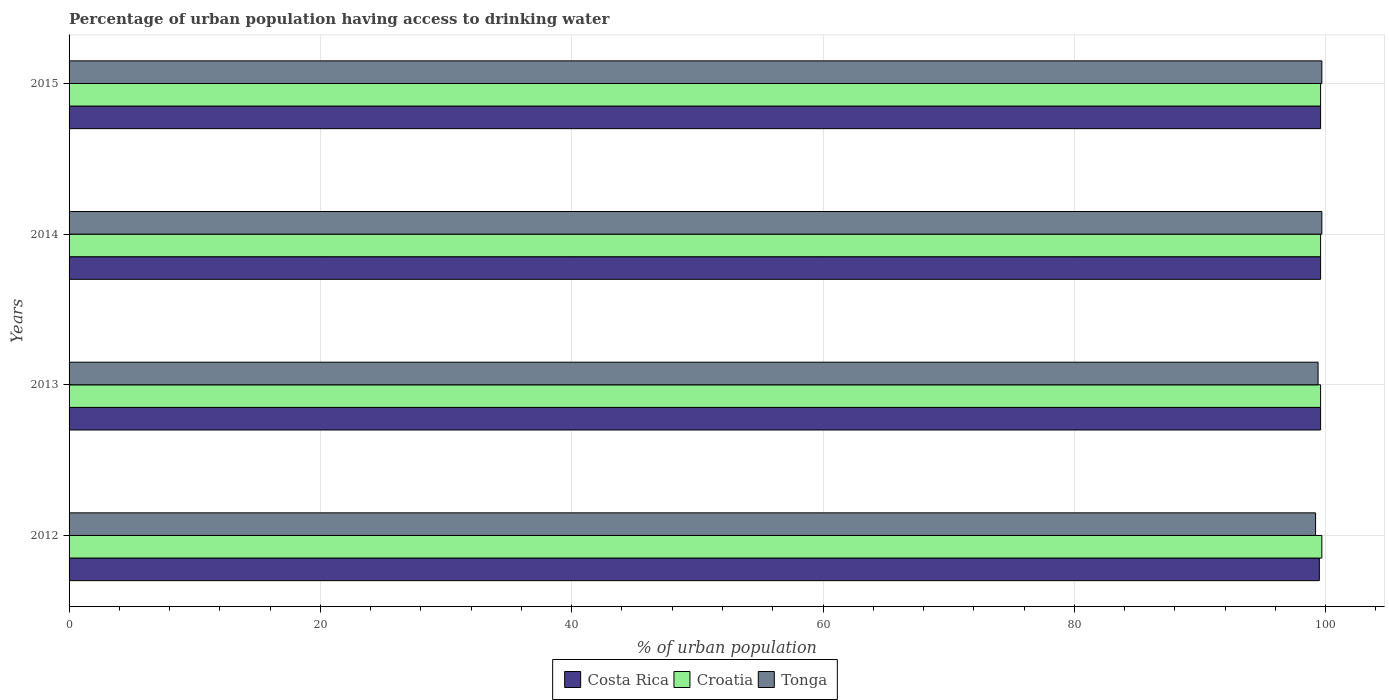How many different coloured bars are there?
Give a very brief answer. 3. Are the number of bars per tick equal to the number of legend labels?
Offer a terse response. Yes. Are the number of bars on each tick of the Y-axis equal?
Offer a very short reply. Yes. How many bars are there on the 2nd tick from the top?
Offer a very short reply. 3. How many bars are there on the 2nd tick from the bottom?
Ensure brevity in your answer.  3. What is the percentage of urban population having access to drinking water in Costa Rica in 2014?
Your answer should be compact. 99.6. Across all years, what is the maximum percentage of urban population having access to drinking water in Tonga?
Make the answer very short. 99.7. Across all years, what is the minimum percentage of urban population having access to drinking water in Costa Rica?
Give a very brief answer. 99.5. What is the total percentage of urban population having access to drinking water in Costa Rica in the graph?
Keep it short and to the point. 398.3. What is the difference between the percentage of urban population having access to drinking water in Tonga in 2012 and that in 2013?
Offer a very short reply. -0.2. What is the difference between the percentage of urban population having access to drinking water in Costa Rica in 2014 and the percentage of urban population having access to drinking water in Croatia in 2012?
Make the answer very short. -0.1. What is the average percentage of urban population having access to drinking water in Croatia per year?
Your response must be concise. 99.62. In the year 2015, what is the difference between the percentage of urban population having access to drinking water in Tonga and percentage of urban population having access to drinking water in Costa Rica?
Your answer should be very brief. 0.1. Is the percentage of urban population having access to drinking water in Costa Rica in 2012 less than that in 2014?
Ensure brevity in your answer.  Yes. What is the difference between the highest and the second highest percentage of urban population having access to drinking water in Costa Rica?
Provide a short and direct response. 0. What is the difference between the highest and the lowest percentage of urban population having access to drinking water in Costa Rica?
Offer a terse response. 0.1. What does the 3rd bar from the top in 2013 represents?
Keep it short and to the point. Costa Rica. What does the 3rd bar from the bottom in 2014 represents?
Your response must be concise. Tonga. Is it the case that in every year, the sum of the percentage of urban population having access to drinking water in Costa Rica and percentage of urban population having access to drinking water in Tonga is greater than the percentage of urban population having access to drinking water in Croatia?
Keep it short and to the point. Yes. How many bars are there?
Your answer should be compact. 12. Are the values on the major ticks of X-axis written in scientific E-notation?
Provide a succinct answer. No. Where does the legend appear in the graph?
Make the answer very short. Bottom center. What is the title of the graph?
Ensure brevity in your answer.  Percentage of urban population having access to drinking water. What is the label or title of the X-axis?
Offer a terse response. % of urban population. What is the % of urban population of Costa Rica in 2012?
Provide a succinct answer. 99.5. What is the % of urban population in Croatia in 2012?
Your answer should be very brief. 99.7. What is the % of urban population of Tonga in 2012?
Your answer should be compact. 99.2. What is the % of urban population of Costa Rica in 2013?
Ensure brevity in your answer.  99.6. What is the % of urban population of Croatia in 2013?
Your response must be concise. 99.6. What is the % of urban population of Tonga in 2013?
Keep it short and to the point. 99.4. What is the % of urban population in Costa Rica in 2014?
Offer a terse response. 99.6. What is the % of urban population in Croatia in 2014?
Make the answer very short. 99.6. What is the % of urban population in Tonga in 2014?
Provide a succinct answer. 99.7. What is the % of urban population of Costa Rica in 2015?
Ensure brevity in your answer.  99.6. What is the % of urban population in Croatia in 2015?
Provide a short and direct response. 99.6. What is the % of urban population of Tonga in 2015?
Ensure brevity in your answer.  99.7. Across all years, what is the maximum % of urban population of Costa Rica?
Provide a short and direct response. 99.6. Across all years, what is the maximum % of urban population of Croatia?
Ensure brevity in your answer.  99.7. Across all years, what is the maximum % of urban population in Tonga?
Make the answer very short. 99.7. Across all years, what is the minimum % of urban population of Costa Rica?
Your answer should be very brief. 99.5. Across all years, what is the minimum % of urban population of Croatia?
Make the answer very short. 99.6. Across all years, what is the minimum % of urban population in Tonga?
Offer a very short reply. 99.2. What is the total % of urban population of Costa Rica in the graph?
Your response must be concise. 398.3. What is the total % of urban population in Croatia in the graph?
Provide a short and direct response. 398.5. What is the total % of urban population in Tonga in the graph?
Provide a succinct answer. 398. What is the difference between the % of urban population in Costa Rica in 2012 and that in 2014?
Give a very brief answer. -0.1. What is the difference between the % of urban population in Tonga in 2012 and that in 2014?
Provide a succinct answer. -0.5. What is the difference between the % of urban population of Croatia in 2012 and that in 2015?
Provide a short and direct response. 0.1. What is the difference between the % of urban population in Tonga in 2012 and that in 2015?
Your answer should be compact. -0.5. What is the difference between the % of urban population of Costa Rica in 2013 and that in 2014?
Your response must be concise. 0. What is the difference between the % of urban population in Croatia in 2013 and that in 2014?
Provide a short and direct response. 0. What is the difference between the % of urban population in Tonga in 2013 and that in 2014?
Provide a succinct answer. -0.3. What is the difference between the % of urban population of Costa Rica in 2013 and that in 2015?
Ensure brevity in your answer.  0. What is the difference between the % of urban population in Croatia in 2013 and that in 2015?
Your response must be concise. 0. What is the difference between the % of urban population of Costa Rica in 2014 and that in 2015?
Keep it short and to the point. 0. What is the difference between the % of urban population of Tonga in 2014 and that in 2015?
Your answer should be very brief. 0. What is the difference between the % of urban population of Costa Rica in 2012 and the % of urban population of Tonga in 2013?
Offer a terse response. 0.1. What is the difference between the % of urban population in Croatia in 2012 and the % of urban population in Tonga in 2013?
Your answer should be compact. 0.3. What is the difference between the % of urban population in Costa Rica in 2012 and the % of urban population in Croatia in 2014?
Keep it short and to the point. -0.1. What is the difference between the % of urban population of Costa Rica in 2012 and the % of urban population of Tonga in 2014?
Make the answer very short. -0.2. What is the difference between the % of urban population of Costa Rica in 2012 and the % of urban population of Croatia in 2015?
Ensure brevity in your answer.  -0.1. What is the difference between the % of urban population of Costa Rica in 2012 and the % of urban population of Tonga in 2015?
Provide a succinct answer. -0.2. What is the difference between the % of urban population of Costa Rica in 2013 and the % of urban population of Croatia in 2014?
Your answer should be very brief. 0. What is the difference between the % of urban population in Costa Rica in 2013 and the % of urban population in Tonga in 2014?
Your answer should be compact. -0.1. What is the difference between the % of urban population of Costa Rica in 2013 and the % of urban population of Tonga in 2015?
Make the answer very short. -0.1. What is the difference between the % of urban population of Croatia in 2013 and the % of urban population of Tonga in 2015?
Offer a very short reply. -0.1. What is the difference between the % of urban population of Costa Rica in 2014 and the % of urban population of Tonga in 2015?
Keep it short and to the point. -0.1. What is the difference between the % of urban population of Croatia in 2014 and the % of urban population of Tonga in 2015?
Provide a short and direct response. -0.1. What is the average % of urban population of Costa Rica per year?
Keep it short and to the point. 99.58. What is the average % of urban population of Croatia per year?
Ensure brevity in your answer.  99.62. What is the average % of urban population of Tonga per year?
Keep it short and to the point. 99.5. In the year 2012, what is the difference between the % of urban population in Croatia and % of urban population in Tonga?
Ensure brevity in your answer.  0.5. In the year 2013, what is the difference between the % of urban population of Costa Rica and % of urban population of Croatia?
Your answer should be very brief. 0. In the year 2013, what is the difference between the % of urban population of Croatia and % of urban population of Tonga?
Give a very brief answer. 0.2. In the year 2014, what is the difference between the % of urban population of Costa Rica and % of urban population of Croatia?
Offer a very short reply. 0. In the year 2014, what is the difference between the % of urban population in Costa Rica and % of urban population in Tonga?
Offer a very short reply. -0.1. In the year 2014, what is the difference between the % of urban population in Croatia and % of urban population in Tonga?
Ensure brevity in your answer.  -0.1. In the year 2015, what is the difference between the % of urban population of Costa Rica and % of urban population of Croatia?
Your answer should be compact. 0. In the year 2015, what is the difference between the % of urban population of Croatia and % of urban population of Tonga?
Ensure brevity in your answer.  -0.1. What is the ratio of the % of urban population of Costa Rica in 2012 to that in 2013?
Your response must be concise. 1. What is the ratio of the % of urban population of Croatia in 2012 to that in 2013?
Provide a succinct answer. 1. What is the ratio of the % of urban population of Tonga in 2012 to that in 2013?
Make the answer very short. 1. What is the ratio of the % of urban population of Costa Rica in 2012 to that in 2014?
Keep it short and to the point. 1. What is the ratio of the % of urban population in Croatia in 2012 to that in 2015?
Ensure brevity in your answer.  1. What is the ratio of the % of urban population in Tonga in 2012 to that in 2015?
Provide a short and direct response. 0.99. What is the ratio of the % of urban population of Croatia in 2013 to that in 2014?
Ensure brevity in your answer.  1. What is the ratio of the % of urban population of Costa Rica in 2013 to that in 2015?
Provide a succinct answer. 1. What is the ratio of the % of urban population of Croatia in 2014 to that in 2015?
Provide a short and direct response. 1. What is the difference between the highest and the lowest % of urban population of Costa Rica?
Your response must be concise. 0.1. What is the difference between the highest and the lowest % of urban population of Tonga?
Provide a succinct answer. 0.5. 